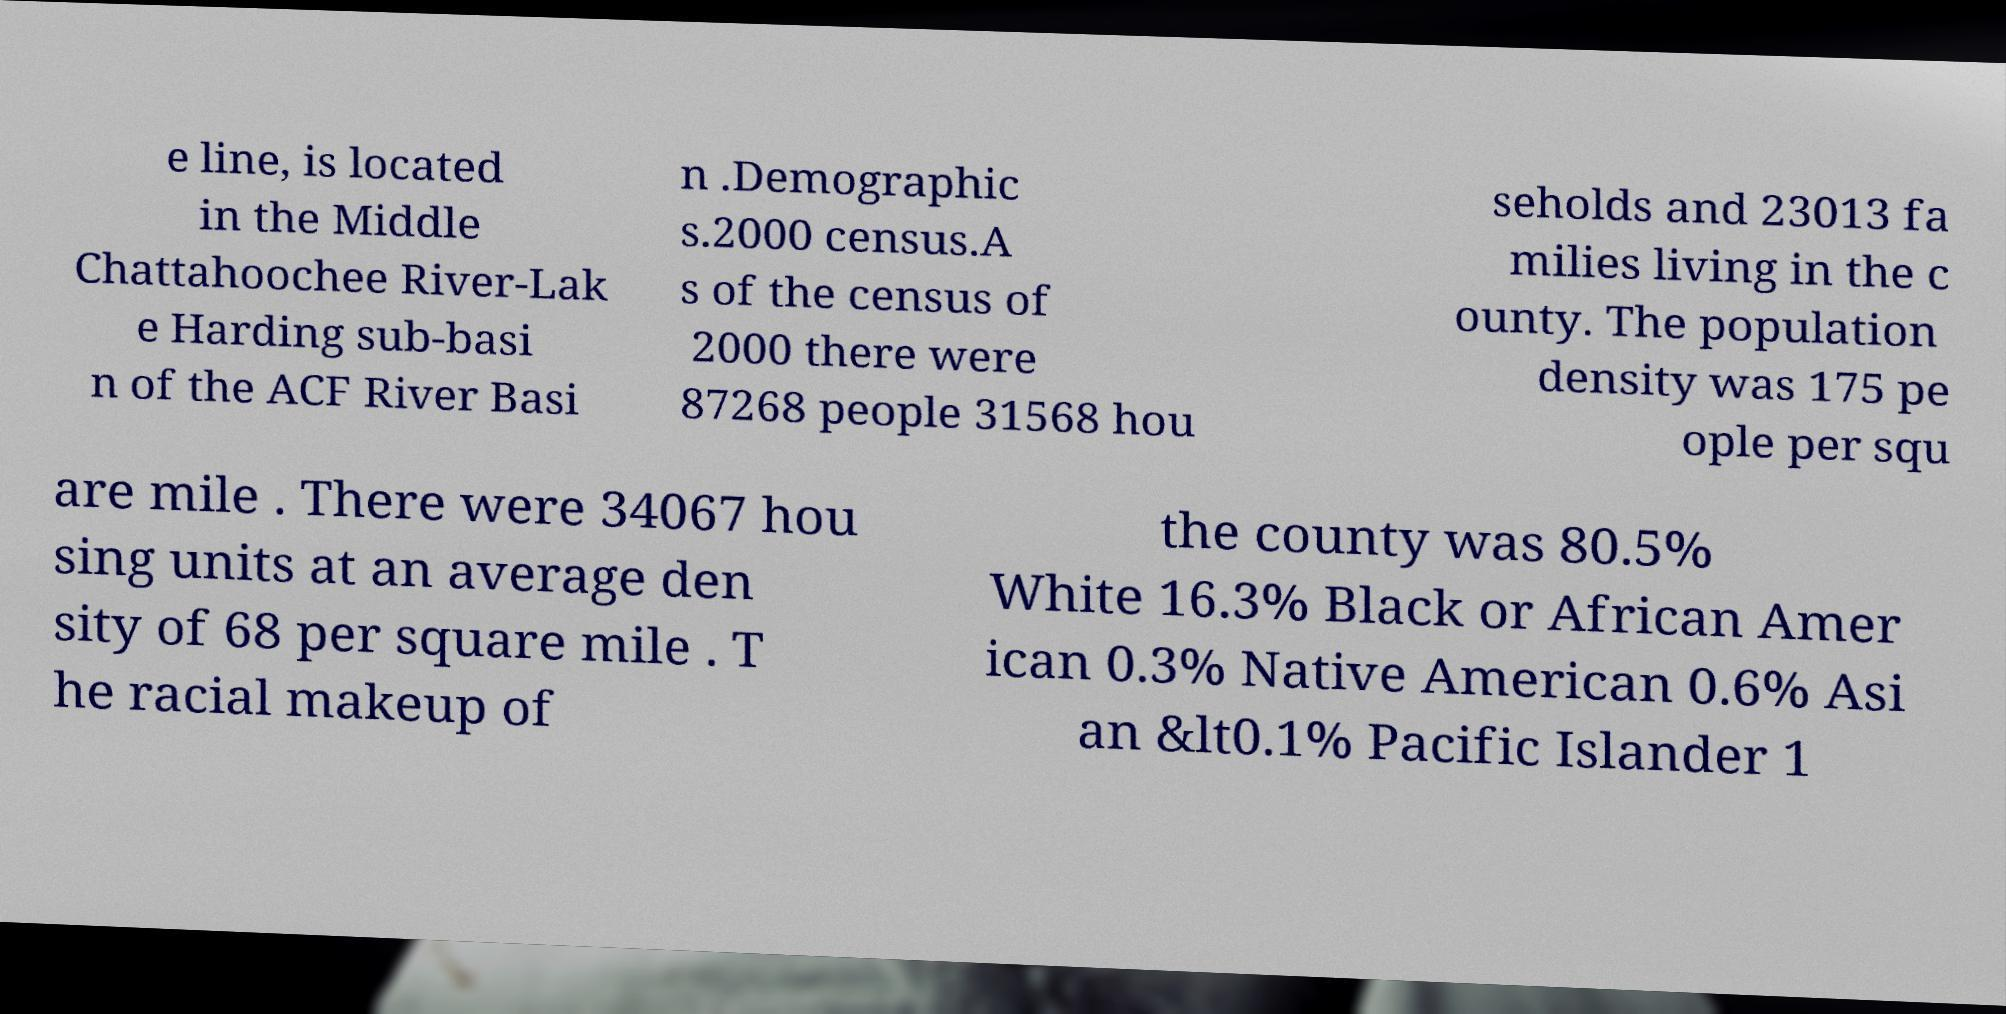There's text embedded in this image that I need extracted. Can you transcribe it verbatim? e line, is located in the Middle Chattahoochee River-Lak e Harding sub-basi n of the ACF River Basi n .Demographic s.2000 census.A s of the census of 2000 there were 87268 people 31568 hou seholds and 23013 fa milies living in the c ounty. The population density was 175 pe ople per squ are mile . There were 34067 hou sing units at an average den sity of 68 per square mile . T he racial makeup of the county was 80.5% White 16.3% Black or African Amer ican 0.3% Native American 0.6% Asi an &lt0.1% Pacific Islander 1 